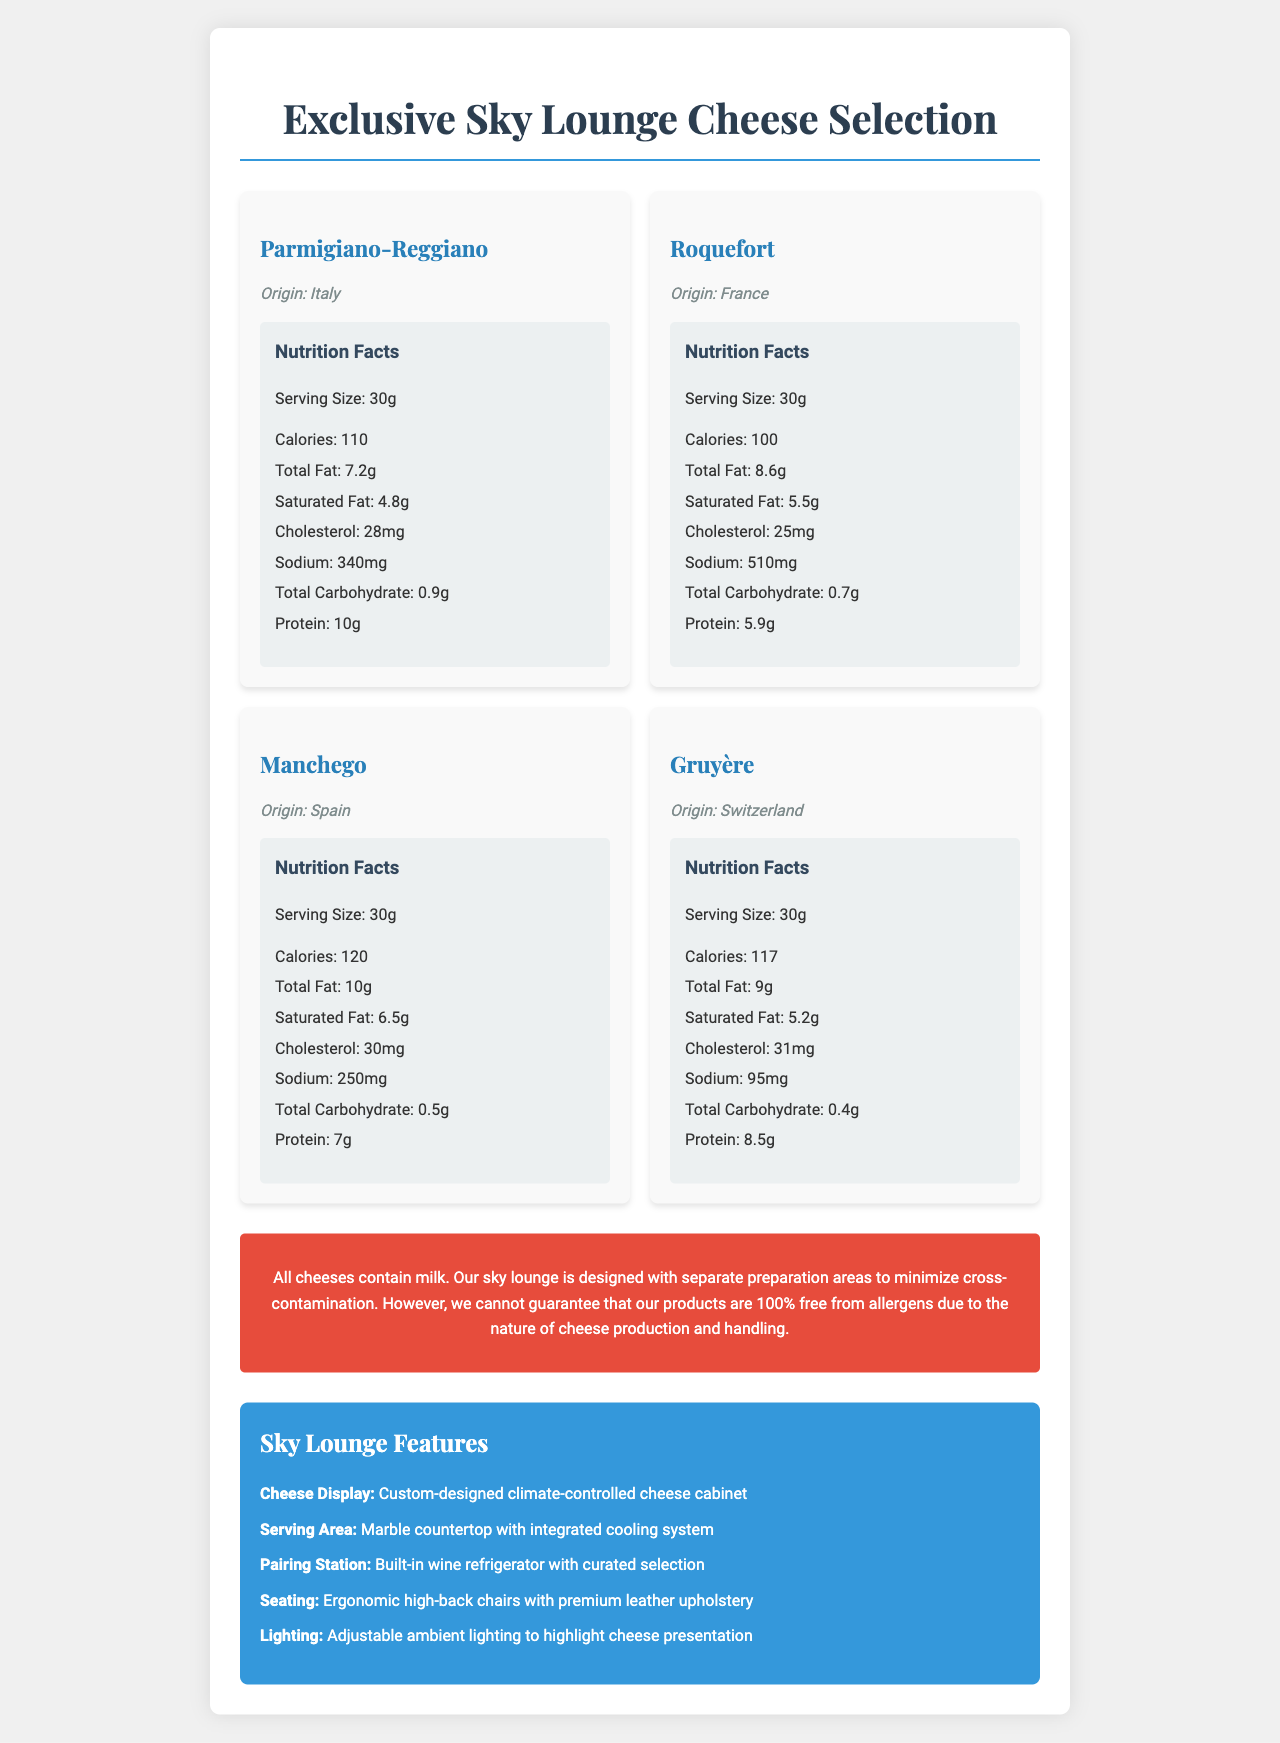What allergen is present in all the cheeses? The document specifies that all the cheeses contain milk as the allergen.
Answer: Milk Which country does Parmigiano-Reggiano originate from? The document lists Parmigiano-Reggiano as originating from Italy.
Answer: Italy What is the serving size for Gruyère? Under the nutrition facts for Gruyère, the serving size is listed as 30 grams.
Answer: 30g How many calories are there in a serving of Manchego? The nutrition facts section for Manchego states that a 30g serving contains 120 calories.
Answer: 120 How much protein does Roquefort contain per serving? Roquefort's nutrition facts mention that it contains 5.9 grams of protein per 30g serving.
Answer: 5.9g Which cheese contains the least sodium? A. Parmigiano-Reggiano B. Roquefort C. Manchego D. Gruyère Gruyère has 95mg of sodium per serving, which is lower than the sodium content in Parmigiano-Reggiano (340mg), Roquefort (510mg), and Manchego (250mg).
Answer: D. Gruyère Which cheese has the highest saturated fat content per serving? A. Parmigiano-Reggiano B. Roquefort C. Manchego D. Gruyère Manchego has 6.5g of saturated fat per serving, which is the highest among Parmigiano-Reggiano (4.8g), Roquefort (5.5g), and Gruyère (5.2g).
Answer: C. Manchego Does the document guarantee that the cheeses are completely allergen-free due to separate preparation areas? The document states that separate preparation areas are designed to minimize cross-contamination, but it does not guarantee that the products are 100% free from allergens.
Answer: No Can you determine the types of cheese knives available from the document? The document does not provide any information about the types of cheese knives available.
Answer: Cannot be determined What is the purpose of the advanced air filtration system installed in the sky lounge? The architect notes specify that the advanced air filtration system is implemented to control cheese aromas in the confined airplane space.
Answer: To control cheese aromas in the confined airplane space What are some features of the sky lounge? Summarize key points. The document describes several features of the sky lounge, including a climate-controlled cheese cabinet, a marble countertop with integrated cooling, a wine refrigerator, ergonomic seating, and adjustable ambient lighting.
Answer: The sky lounge features a custom-designed climate-controlled cheese cabinet, a marble countertop with an integrated cooling system, a built-in wine refrigerator with a curated selection, ergonomic high-back chairs with premium leather upholstery, and adjustable ambient lighting to highlight the cheese presentation. What material was used for the cheese storage and preparation areas to ensure hygiene? The architect notes mention that food-grade stainless steel and easy-to-clean surfaces were used for hygienic cheese storage and preparation.
Answer: Food-grade stainless steel and easy-to-clean surfaces What is the origin of Roquefort cheese? According to the document, Roquefort cheese originates from France.
Answer: France How much total carbohydrate does a serving of Parmigiano-Reggiano contain? The nutrition facts for Parmigiano-Reggiano show that it contains 0.9 grams of total carbohydrate per serving.
Answer: 0.9g What is the total fat content in a serving of Gruyère? The document states that a 30g serving of Gruyère contains 9 grams of total fat.
Answer: 9g What additional feature does the serving area in the sky lounge have? The sky lounge features section mentions that the serving area has a marble countertop with an integrated cooling system.
Answer: Integrated cooling system 